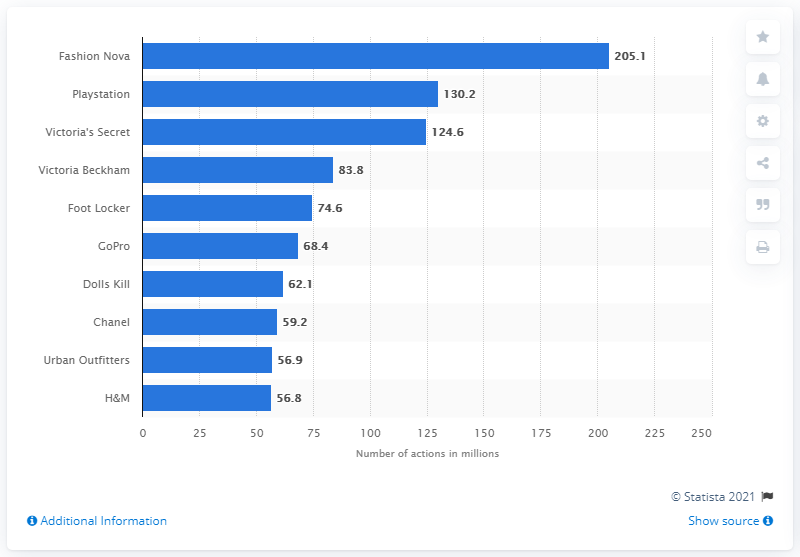Highlight a few significant elements in this photo. According to available data, it is reported that Fashion Nova was the most popular retail brand in the United States in 2020. In 2020, Fashion Nova had a total of 205.1 cross-platform actions on social media. Playstation generated 130.2 social media actions on brand-owned content. 